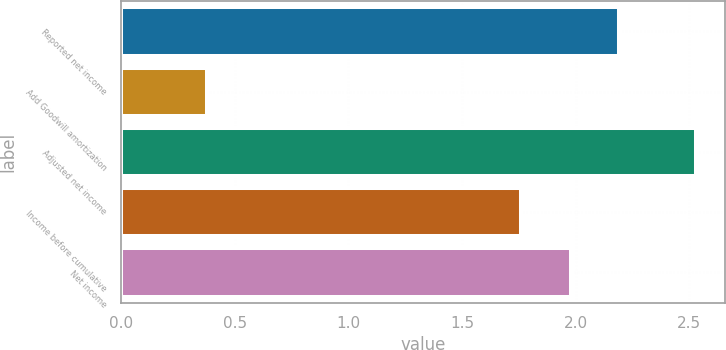<chart> <loc_0><loc_0><loc_500><loc_500><bar_chart><fcel>Reported net income<fcel>Add Goodwill amortization<fcel>Adjusted net income<fcel>Income before cumulative<fcel>Net income<nl><fcel>2.19<fcel>0.38<fcel>2.53<fcel>1.76<fcel>1.98<nl></chart> 